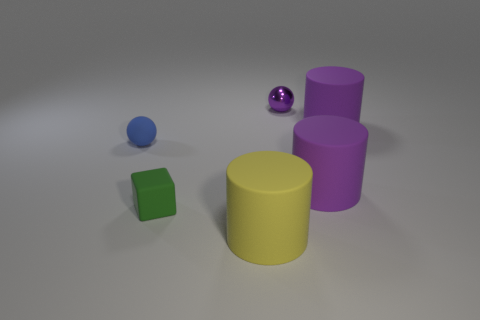Subtract all large purple cylinders. How many cylinders are left? 1 Add 1 green rubber things. How many objects exist? 7 Subtract all yellow cubes. How many purple cylinders are left? 2 Subtract all yellow cylinders. How many cylinders are left? 2 Subtract all cubes. How many objects are left? 5 Add 6 small objects. How many small objects exist? 9 Subtract 0 brown blocks. How many objects are left? 6 Subtract all blue balls. Subtract all green cylinders. How many balls are left? 1 Subtract all blocks. Subtract all large cylinders. How many objects are left? 2 Add 6 purple rubber cylinders. How many purple rubber cylinders are left? 8 